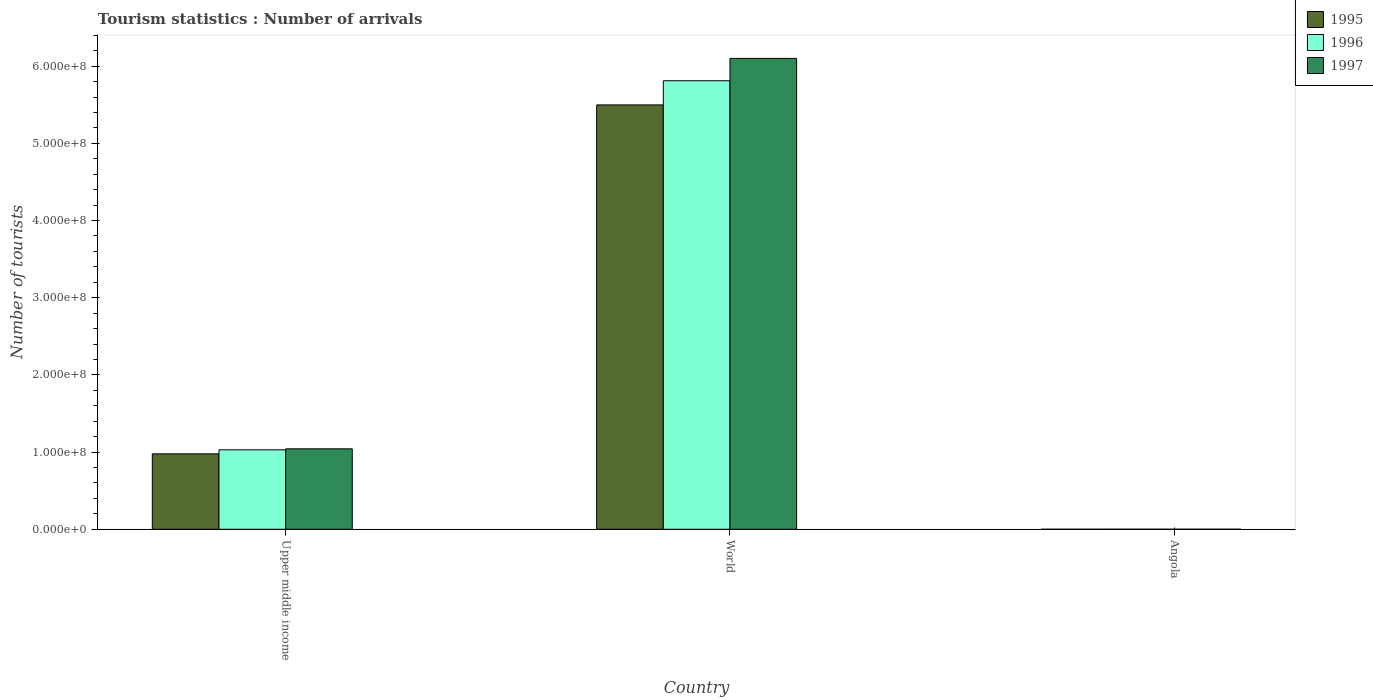How many groups of bars are there?
Offer a terse response. 3. Are the number of bars per tick equal to the number of legend labels?
Offer a terse response. Yes. How many bars are there on the 2nd tick from the right?
Provide a succinct answer. 3. What is the label of the 3rd group of bars from the left?
Provide a short and direct response. Angola. In how many cases, is the number of bars for a given country not equal to the number of legend labels?
Offer a very short reply. 0. What is the number of tourist arrivals in 1995 in Angola?
Give a very brief answer. 9000. Across all countries, what is the maximum number of tourist arrivals in 1997?
Keep it short and to the point. 6.10e+08. Across all countries, what is the minimum number of tourist arrivals in 1997?
Provide a short and direct response. 4.50e+04. In which country was the number of tourist arrivals in 1997 minimum?
Make the answer very short. Angola. What is the total number of tourist arrivals in 1997 in the graph?
Your answer should be compact. 7.14e+08. What is the difference between the number of tourist arrivals in 1997 in Angola and that in Upper middle income?
Provide a short and direct response. -1.04e+08. What is the difference between the number of tourist arrivals in 1995 in World and the number of tourist arrivals in 1997 in Angola?
Give a very brief answer. 5.50e+08. What is the average number of tourist arrivals in 1996 per country?
Provide a succinct answer. 2.28e+08. What is the difference between the number of tourist arrivals of/in 1995 and number of tourist arrivals of/in 1997 in Upper middle income?
Offer a terse response. -6.47e+06. What is the ratio of the number of tourist arrivals in 1995 in Angola to that in Upper middle income?
Your answer should be compact. 9.207107144402005e-5. Is the number of tourist arrivals in 1997 in Upper middle income less than that in World?
Offer a very short reply. Yes. Is the difference between the number of tourist arrivals in 1995 in Angola and World greater than the difference between the number of tourist arrivals in 1997 in Angola and World?
Your answer should be very brief. Yes. What is the difference between the highest and the second highest number of tourist arrivals in 1996?
Offer a terse response. 4.78e+08. What is the difference between the highest and the lowest number of tourist arrivals in 1996?
Make the answer very short. 5.81e+08. Is the sum of the number of tourist arrivals in 1997 in Angola and World greater than the maximum number of tourist arrivals in 1996 across all countries?
Ensure brevity in your answer.  Yes. Is it the case that in every country, the sum of the number of tourist arrivals in 1996 and number of tourist arrivals in 1997 is greater than the number of tourist arrivals in 1995?
Your response must be concise. Yes. Are all the bars in the graph horizontal?
Give a very brief answer. No. How many countries are there in the graph?
Provide a short and direct response. 3. What is the difference between two consecutive major ticks on the Y-axis?
Give a very brief answer. 1.00e+08. Are the values on the major ticks of Y-axis written in scientific E-notation?
Provide a short and direct response. Yes. Does the graph contain grids?
Offer a very short reply. No. Where does the legend appear in the graph?
Offer a terse response. Top right. What is the title of the graph?
Ensure brevity in your answer.  Tourism statistics : Number of arrivals. Does "1988" appear as one of the legend labels in the graph?
Offer a very short reply. No. What is the label or title of the Y-axis?
Give a very brief answer. Number of tourists. What is the Number of tourists in 1995 in Upper middle income?
Keep it short and to the point. 9.78e+07. What is the Number of tourists of 1996 in Upper middle income?
Offer a very short reply. 1.03e+08. What is the Number of tourists of 1997 in Upper middle income?
Keep it short and to the point. 1.04e+08. What is the Number of tourists in 1995 in World?
Provide a short and direct response. 5.50e+08. What is the Number of tourists in 1996 in World?
Your response must be concise. 5.81e+08. What is the Number of tourists in 1997 in World?
Your response must be concise. 6.10e+08. What is the Number of tourists of 1995 in Angola?
Make the answer very short. 9000. What is the Number of tourists in 1996 in Angola?
Give a very brief answer. 2.10e+04. What is the Number of tourists in 1997 in Angola?
Ensure brevity in your answer.  4.50e+04. Across all countries, what is the maximum Number of tourists of 1995?
Ensure brevity in your answer.  5.50e+08. Across all countries, what is the maximum Number of tourists in 1996?
Provide a succinct answer. 5.81e+08. Across all countries, what is the maximum Number of tourists of 1997?
Ensure brevity in your answer.  6.10e+08. Across all countries, what is the minimum Number of tourists in 1995?
Provide a succinct answer. 9000. Across all countries, what is the minimum Number of tourists in 1996?
Provide a succinct answer. 2.10e+04. Across all countries, what is the minimum Number of tourists in 1997?
Ensure brevity in your answer.  4.50e+04. What is the total Number of tourists in 1995 in the graph?
Provide a succinct answer. 6.48e+08. What is the total Number of tourists of 1996 in the graph?
Your response must be concise. 6.84e+08. What is the total Number of tourists of 1997 in the graph?
Offer a very short reply. 7.14e+08. What is the difference between the Number of tourists in 1995 in Upper middle income and that in World?
Provide a short and direct response. -4.52e+08. What is the difference between the Number of tourists of 1996 in Upper middle income and that in World?
Make the answer very short. -4.78e+08. What is the difference between the Number of tourists in 1997 in Upper middle income and that in World?
Ensure brevity in your answer.  -5.06e+08. What is the difference between the Number of tourists of 1995 in Upper middle income and that in Angola?
Provide a short and direct response. 9.77e+07. What is the difference between the Number of tourists in 1996 in Upper middle income and that in Angola?
Your answer should be compact. 1.03e+08. What is the difference between the Number of tourists in 1997 in Upper middle income and that in Angola?
Provide a short and direct response. 1.04e+08. What is the difference between the Number of tourists in 1995 in World and that in Angola?
Your answer should be very brief. 5.50e+08. What is the difference between the Number of tourists in 1996 in World and that in Angola?
Provide a short and direct response. 5.81e+08. What is the difference between the Number of tourists in 1997 in World and that in Angola?
Keep it short and to the point. 6.10e+08. What is the difference between the Number of tourists of 1995 in Upper middle income and the Number of tourists of 1996 in World?
Your answer should be compact. -4.83e+08. What is the difference between the Number of tourists of 1995 in Upper middle income and the Number of tourists of 1997 in World?
Give a very brief answer. -5.12e+08. What is the difference between the Number of tourists in 1996 in Upper middle income and the Number of tourists in 1997 in World?
Keep it short and to the point. -5.07e+08. What is the difference between the Number of tourists of 1995 in Upper middle income and the Number of tourists of 1996 in Angola?
Ensure brevity in your answer.  9.77e+07. What is the difference between the Number of tourists in 1995 in Upper middle income and the Number of tourists in 1997 in Angola?
Offer a terse response. 9.77e+07. What is the difference between the Number of tourists of 1996 in Upper middle income and the Number of tourists of 1997 in Angola?
Keep it short and to the point. 1.03e+08. What is the difference between the Number of tourists in 1995 in World and the Number of tourists in 1996 in Angola?
Give a very brief answer. 5.50e+08. What is the difference between the Number of tourists in 1995 in World and the Number of tourists in 1997 in Angola?
Make the answer very short. 5.50e+08. What is the difference between the Number of tourists of 1996 in World and the Number of tourists of 1997 in Angola?
Ensure brevity in your answer.  5.81e+08. What is the average Number of tourists in 1995 per country?
Give a very brief answer. 2.16e+08. What is the average Number of tourists in 1996 per country?
Your response must be concise. 2.28e+08. What is the average Number of tourists in 1997 per country?
Make the answer very short. 2.38e+08. What is the difference between the Number of tourists of 1995 and Number of tourists of 1996 in Upper middle income?
Your answer should be very brief. -5.20e+06. What is the difference between the Number of tourists of 1995 and Number of tourists of 1997 in Upper middle income?
Offer a terse response. -6.47e+06. What is the difference between the Number of tourists in 1996 and Number of tourists in 1997 in Upper middle income?
Offer a terse response. -1.27e+06. What is the difference between the Number of tourists of 1995 and Number of tourists of 1996 in World?
Give a very brief answer. -3.13e+07. What is the difference between the Number of tourists of 1995 and Number of tourists of 1997 in World?
Provide a short and direct response. -6.02e+07. What is the difference between the Number of tourists in 1996 and Number of tourists in 1997 in World?
Your response must be concise. -2.89e+07. What is the difference between the Number of tourists of 1995 and Number of tourists of 1996 in Angola?
Ensure brevity in your answer.  -1.20e+04. What is the difference between the Number of tourists of 1995 and Number of tourists of 1997 in Angola?
Your answer should be compact. -3.60e+04. What is the difference between the Number of tourists in 1996 and Number of tourists in 1997 in Angola?
Keep it short and to the point. -2.40e+04. What is the ratio of the Number of tourists of 1995 in Upper middle income to that in World?
Your answer should be compact. 0.18. What is the ratio of the Number of tourists in 1996 in Upper middle income to that in World?
Provide a short and direct response. 0.18. What is the ratio of the Number of tourists in 1997 in Upper middle income to that in World?
Your answer should be compact. 0.17. What is the ratio of the Number of tourists in 1995 in Upper middle income to that in Angola?
Your answer should be compact. 1.09e+04. What is the ratio of the Number of tourists of 1996 in Upper middle income to that in Angola?
Make the answer very short. 4902.39. What is the ratio of the Number of tourists of 1997 in Upper middle income to that in Angola?
Your response must be concise. 2316.1. What is the ratio of the Number of tourists in 1995 in World to that in Angola?
Give a very brief answer. 6.11e+04. What is the ratio of the Number of tourists of 1996 in World to that in Angola?
Give a very brief answer. 2.77e+04. What is the ratio of the Number of tourists of 1997 in World to that in Angola?
Your response must be concise. 1.36e+04. What is the difference between the highest and the second highest Number of tourists in 1995?
Your answer should be compact. 4.52e+08. What is the difference between the highest and the second highest Number of tourists of 1996?
Provide a succinct answer. 4.78e+08. What is the difference between the highest and the second highest Number of tourists in 1997?
Keep it short and to the point. 5.06e+08. What is the difference between the highest and the lowest Number of tourists in 1995?
Your answer should be compact. 5.50e+08. What is the difference between the highest and the lowest Number of tourists of 1996?
Your answer should be very brief. 5.81e+08. What is the difference between the highest and the lowest Number of tourists of 1997?
Keep it short and to the point. 6.10e+08. 